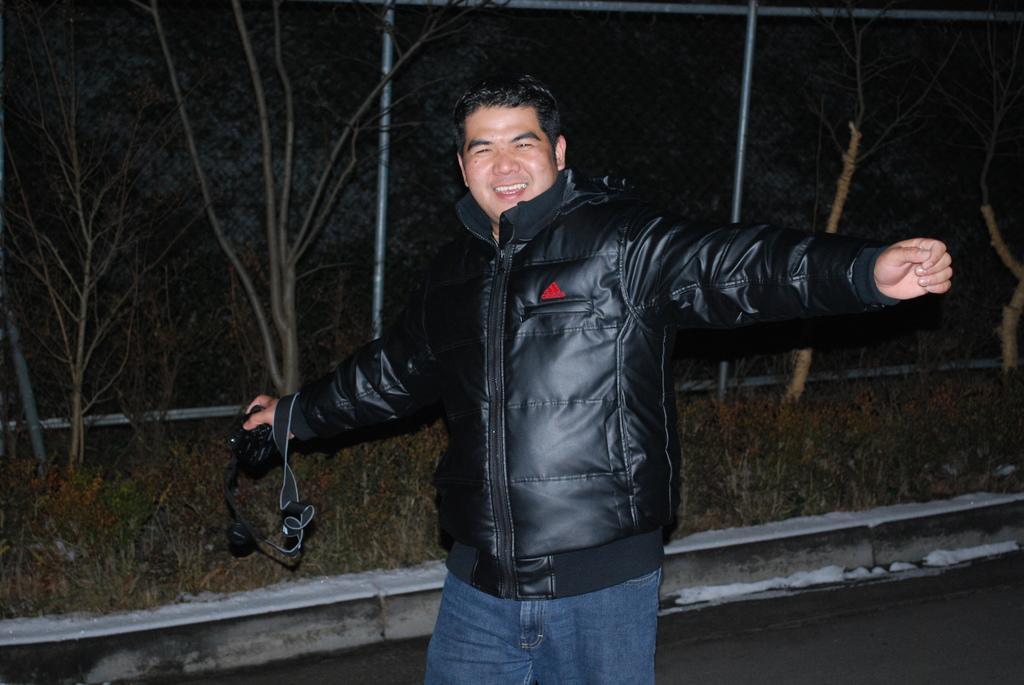Please provide a concise description of this image. This picture is clicked outside. In the center there is a person wearing black color jacket, holding an object and seems to be standing. In the background we can see the plants and trees and some metal rods. 